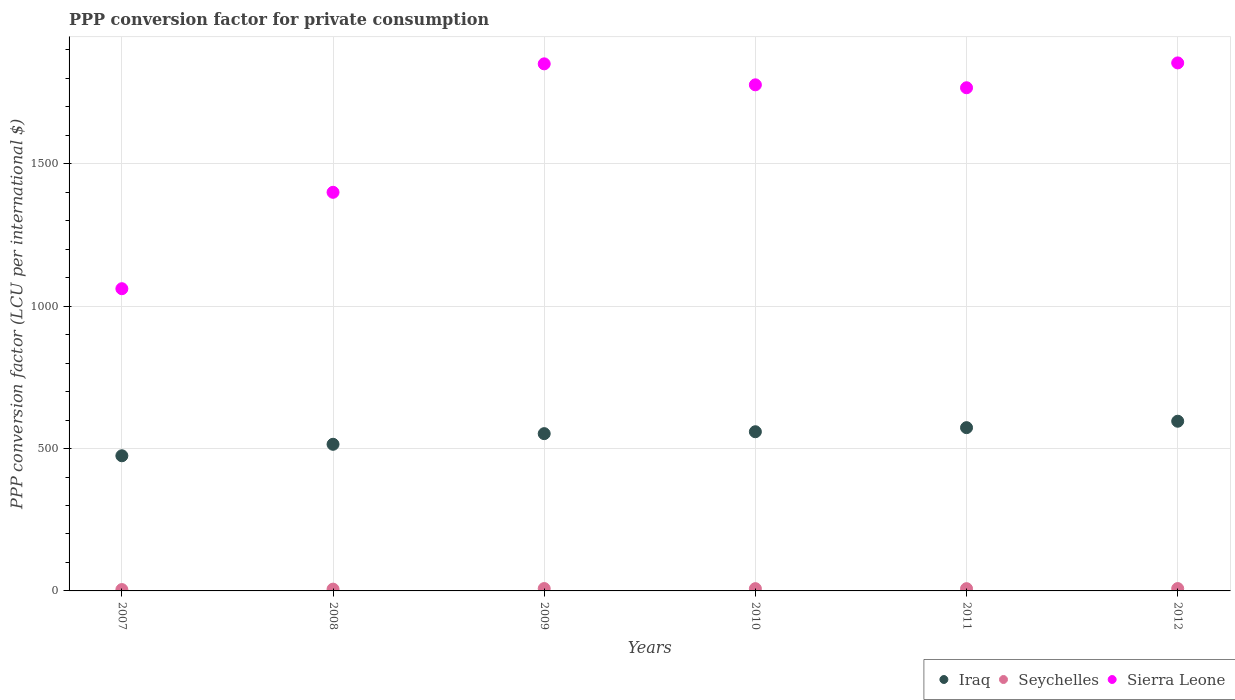How many different coloured dotlines are there?
Provide a short and direct response. 3. What is the PPP conversion factor for private consumption in Sierra Leone in 2009?
Your answer should be very brief. 1851.15. Across all years, what is the maximum PPP conversion factor for private consumption in Iraq?
Give a very brief answer. 596. Across all years, what is the minimum PPP conversion factor for private consumption in Sierra Leone?
Ensure brevity in your answer.  1061.41. In which year was the PPP conversion factor for private consumption in Sierra Leone maximum?
Your answer should be compact. 2012. What is the total PPP conversion factor for private consumption in Seychelles in the graph?
Keep it short and to the point. 43.39. What is the difference between the PPP conversion factor for private consumption in Iraq in 2009 and that in 2010?
Offer a very short reply. -6.73. What is the difference between the PPP conversion factor for private consumption in Iraq in 2007 and the PPP conversion factor for private consumption in Sierra Leone in 2008?
Keep it short and to the point. -925.34. What is the average PPP conversion factor for private consumption in Sierra Leone per year?
Your answer should be very brief. 1618.62. In the year 2010, what is the difference between the PPP conversion factor for private consumption in Sierra Leone and PPP conversion factor for private consumption in Seychelles?
Offer a terse response. 1769.55. What is the ratio of the PPP conversion factor for private consumption in Sierra Leone in 2008 to that in 2011?
Offer a terse response. 0.79. Is the difference between the PPP conversion factor for private consumption in Sierra Leone in 2007 and 2010 greater than the difference between the PPP conversion factor for private consumption in Seychelles in 2007 and 2010?
Give a very brief answer. No. What is the difference between the highest and the second highest PPP conversion factor for private consumption in Seychelles?
Keep it short and to the point. 0.01. What is the difference between the highest and the lowest PPP conversion factor for private consumption in Seychelles?
Ensure brevity in your answer.  3.54. In how many years, is the PPP conversion factor for private consumption in Iraq greater than the average PPP conversion factor for private consumption in Iraq taken over all years?
Offer a terse response. 4. Is the sum of the PPP conversion factor for private consumption in Sierra Leone in 2007 and 2009 greater than the maximum PPP conversion factor for private consumption in Seychelles across all years?
Offer a terse response. Yes. Is the PPP conversion factor for private consumption in Sierra Leone strictly less than the PPP conversion factor for private consumption in Seychelles over the years?
Provide a succinct answer. No. How many dotlines are there?
Your answer should be very brief. 3. Does the graph contain any zero values?
Your answer should be compact. No. How many legend labels are there?
Your response must be concise. 3. How are the legend labels stacked?
Provide a short and direct response. Horizontal. What is the title of the graph?
Offer a terse response. PPP conversion factor for private consumption. What is the label or title of the X-axis?
Offer a terse response. Years. What is the label or title of the Y-axis?
Give a very brief answer. PPP conversion factor (LCU per international $). What is the PPP conversion factor (LCU per international $) in Iraq in 2007?
Offer a very short reply. 474.66. What is the PPP conversion factor (LCU per international $) of Seychelles in 2007?
Your answer should be very brief. 4.74. What is the PPP conversion factor (LCU per international $) in Sierra Leone in 2007?
Provide a succinct answer. 1061.41. What is the PPP conversion factor (LCU per international $) in Iraq in 2008?
Offer a terse response. 515. What is the PPP conversion factor (LCU per international $) of Seychelles in 2008?
Give a very brief answer. 6.25. What is the PPP conversion factor (LCU per international $) in Sierra Leone in 2008?
Offer a very short reply. 1400.01. What is the PPP conversion factor (LCU per international $) of Iraq in 2009?
Keep it short and to the point. 552.36. What is the PPP conversion factor (LCU per international $) in Seychelles in 2009?
Ensure brevity in your answer.  8.27. What is the PPP conversion factor (LCU per international $) in Sierra Leone in 2009?
Give a very brief answer. 1851.15. What is the PPP conversion factor (LCU per international $) of Iraq in 2010?
Your answer should be very brief. 559.09. What is the PPP conversion factor (LCU per international $) in Seychelles in 2010?
Your answer should be very brief. 7.94. What is the PPP conversion factor (LCU per international $) of Sierra Leone in 2010?
Offer a very short reply. 1777.49. What is the PPP conversion factor (LCU per international $) of Iraq in 2011?
Give a very brief answer. 573.42. What is the PPP conversion factor (LCU per international $) in Seychelles in 2011?
Give a very brief answer. 7.9. What is the PPP conversion factor (LCU per international $) of Sierra Leone in 2011?
Ensure brevity in your answer.  1767.19. What is the PPP conversion factor (LCU per international $) of Iraq in 2012?
Provide a short and direct response. 596. What is the PPP conversion factor (LCU per international $) of Seychelles in 2012?
Offer a very short reply. 8.29. What is the PPP conversion factor (LCU per international $) in Sierra Leone in 2012?
Your answer should be compact. 1854.47. Across all years, what is the maximum PPP conversion factor (LCU per international $) of Iraq?
Provide a succinct answer. 596. Across all years, what is the maximum PPP conversion factor (LCU per international $) of Seychelles?
Your answer should be very brief. 8.29. Across all years, what is the maximum PPP conversion factor (LCU per international $) in Sierra Leone?
Keep it short and to the point. 1854.47. Across all years, what is the minimum PPP conversion factor (LCU per international $) in Iraq?
Give a very brief answer. 474.66. Across all years, what is the minimum PPP conversion factor (LCU per international $) in Seychelles?
Your answer should be compact. 4.74. Across all years, what is the minimum PPP conversion factor (LCU per international $) in Sierra Leone?
Provide a succinct answer. 1061.41. What is the total PPP conversion factor (LCU per international $) in Iraq in the graph?
Your response must be concise. 3270.52. What is the total PPP conversion factor (LCU per international $) of Seychelles in the graph?
Make the answer very short. 43.39. What is the total PPP conversion factor (LCU per international $) in Sierra Leone in the graph?
Your answer should be compact. 9711.71. What is the difference between the PPP conversion factor (LCU per international $) in Iraq in 2007 and that in 2008?
Provide a succinct answer. -40.33. What is the difference between the PPP conversion factor (LCU per international $) of Seychelles in 2007 and that in 2008?
Your answer should be compact. -1.51. What is the difference between the PPP conversion factor (LCU per international $) in Sierra Leone in 2007 and that in 2008?
Your answer should be very brief. -338.6. What is the difference between the PPP conversion factor (LCU per international $) in Iraq in 2007 and that in 2009?
Keep it short and to the point. -77.7. What is the difference between the PPP conversion factor (LCU per international $) of Seychelles in 2007 and that in 2009?
Your answer should be very brief. -3.53. What is the difference between the PPP conversion factor (LCU per international $) of Sierra Leone in 2007 and that in 2009?
Keep it short and to the point. -789.74. What is the difference between the PPP conversion factor (LCU per international $) of Iraq in 2007 and that in 2010?
Give a very brief answer. -84.42. What is the difference between the PPP conversion factor (LCU per international $) of Seychelles in 2007 and that in 2010?
Your answer should be very brief. -3.2. What is the difference between the PPP conversion factor (LCU per international $) in Sierra Leone in 2007 and that in 2010?
Offer a very short reply. -716.08. What is the difference between the PPP conversion factor (LCU per international $) of Iraq in 2007 and that in 2011?
Your answer should be very brief. -98.76. What is the difference between the PPP conversion factor (LCU per international $) of Seychelles in 2007 and that in 2011?
Provide a short and direct response. -3.15. What is the difference between the PPP conversion factor (LCU per international $) of Sierra Leone in 2007 and that in 2011?
Keep it short and to the point. -705.78. What is the difference between the PPP conversion factor (LCU per international $) of Iraq in 2007 and that in 2012?
Give a very brief answer. -121.34. What is the difference between the PPP conversion factor (LCU per international $) in Seychelles in 2007 and that in 2012?
Offer a terse response. -3.54. What is the difference between the PPP conversion factor (LCU per international $) in Sierra Leone in 2007 and that in 2012?
Keep it short and to the point. -793.06. What is the difference between the PPP conversion factor (LCU per international $) in Iraq in 2008 and that in 2009?
Your answer should be very brief. -37.36. What is the difference between the PPP conversion factor (LCU per international $) of Seychelles in 2008 and that in 2009?
Provide a succinct answer. -2.02. What is the difference between the PPP conversion factor (LCU per international $) of Sierra Leone in 2008 and that in 2009?
Offer a very short reply. -451.15. What is the difference between the PPP conversion factor (LCU per international $) of Iraq in 2008 and that in 2010?
Your response must be concise. -44.09. What is the difference between the PPP conversion factor (LCU per international $) of Seychelles in 2008 and that in 2010?
Provide a succinct answer. -1.69. What is the difference between the PPP conversion factor (LCU per international $) in Sierra Leone in 2008 and that in 2010?
Provide a short and direct response. -377.48. What is the difference between the PPP conversion factor (LCU per international $) of Iraq in 2008 and that in 2011?
Make the answer very short. -58.42. What is the difference between the PPP conversion factor (LCU per international $) in Seychelles in 2008 and that in 2011?
Your answer should be compact. -1.64. What is the difference between the PPP conversion factor (LCU per international $) in Sierra Leone in 2008 and that in 2011?
Offer a terse response. -367.18. What is the difference between the PPP conversion factor (LCU per international $) of Iraq in 2008 and that in 2012?
Provide a succinct answer. -81. What is the difference between the PPP conversion factor (LCU per international $) of Seychelles in 2008 and that in 2012?
Keep it short and to the point. -2.03. What is the difference between the PPP conversion factor (LCU per international $) of Sierra Leone in 2008 and that in 2012?
Give a very brief answer. -454.46. What is the difference between the PPP conversion factor (LCU per international $) in Iraq in 2009 and that in 2010?
Your response must be concise. -6.73. What is the difference between the PPP conversion factor (LCU per international $) in Seychelles in 2009 and that in 2010?
Ensure brevity in your answer.  0.33. What is the difference between the PPP conversion factor (LCU per international $) in Sierra Leone in 2009 and that in 2010?
Offer a very short reply. 73.67. What is the difference between the PPP conversion factor (LCU per international $) in Iraq in 2009 and that in 2011?
Make the answer very short. -21.06. What is the difference between the PPP conversion factor (LCU per international $) of Seychelles in 2009 and that in 2011?
Give a very brief answer. 0.38. What is the difference between the PPP conversion factor (LCU per international $) of Sierra Leone in 2009 and that in 2011?
Provide a short and direct response. 83.96. What is the difference between the PPP conversion factor (LCU per international $) of Iraq in 2009 and that in 2012?
Your answer should be compact. -43.64. What is the difference between the PPP conversion factor (LCU per international $) in Seychelles in 2009 and that in 2012?
Your answer should be compact. -0.01. What is the difference between the PPP conversion factor (LCU per international $) in Sierra Leone in 2009 and that in 2012?
Offer a terse response. -3.32. What is the difference between the PPP conversion factor (LCU per international $) in Iraq in 2010 and that in 2011?
Ensure brevity in your answer.  -14.33. What is the difference between the PPP conversion factor (LCU per international $) in Seychelles in 2010 and that in 2011?
Ensure brevity in your answer.  0.05. What is the difference between the PPP conversion factor (LCU per international $) in Sierra Leone in 2010 and that in 2011?
Provide a short and direct response. 10.3. What is the difference between the PPP conversion factor (LCU per international $) of Iraq in 2010 and that in 2012?
Give a very brief answer. -36.92. What is the difference between the PPP conversion factor (LCU per international $) in Seychelles in 2010 and that in 2012?
Give a very brief answer. -0.34. What is the difference between the PPP conversion factor (LCU per international $) in Sierra Leone in 2010 and that in 2012?
Your answer should be very brief. -76.98. What is the difference between the PPP conversion factor (LCU per international $) of Iraq in 2011 and that in 2012?
Your response must be concise. -22.58. What is the difference between the PPP conversion factor (LCU per international $) of Seychelles in 2011 and that in 2012?
Keep it short and to the point. -0.39. What is the difference between the PPP conversion factor (LCU per international $) of Sierra Leone in 2011 and that in 2012?
Your answer should be very brief. -87.28. What is the difference between the PPP conversion factor (LCU per international $) of Iraq in 2007 and the PPP conversion factor (LCU per international $) of Seychelles in 2008?
Offer a terse response. 468.41. What is the difference between the PPP conversion factor (LCU per international $) of Iraq in 2007 and the PPP conversion factor (LCU per international $) of Sierra Leone in 2008?
Offer a terse response. -925.34. What is the difference between the PPP conversion factor (LCU per international $) of Seychelles in 2007 and the PPP conversion factor (LCU per international $) of Sierra Leone in 2008?
Offer a very short reply. -1395.26. What is the difference between the PPP conversion factor (LCU per international $) of Iraq in 2007 and the PPP conversion factor (LCU per international $) of Seychelles in 2009?
Give a very brief answer. 466.39. What is the difference between the PPP conversion factor (LCU per international $) in Iraq in 2007 and the PPP conversion factor (LCU per international $) in Sierra Leone in 2009?
Make the answer very short. -1376.49. What is the difference between the PPP conversion factor (LCU per international $) of Seychelles in 2007 and the PPP conversion factor (LCU per international $) of Sierra Leone in 2009?
Your response must be concise. -1846.41. What is the difference between the PPP conversion factor (LCU per international $) of Iraq in 2007 and the PPP conversion factor (LCU per international $) of Seychelles in 2010?
Your answer should be compact. 466.72. What is the difference between the PPP conversion factor (LCU per international $) of Iraq in 2007 and the PPP conversion factor (LCU per international $) of Sierra Leone in 2010?
Your response must be concise. -1302.82. What is the difference between the PPP conversion factor (LCU per international $) of Seychelles in 2007 and the PPP conversion factor (LCU per international $) of Sierra Leone in 2010?
Your answer should be very brief. -1772.74. What is the difference between the PPP conversion factor (LCU per international $) in Iraq in 2007 and the PPP conversion factor (LCU per international $) in Seychelles in 2011?
Your answer should be very brief. 466.77. What is the difference between the PPP conversion factor (LCU per international $) of Iraq in 2007 and the PPP conversion factor (LCU per international $) of Sierra Leone in 2011?
Offer a terse response. -1292.53. What is the difference between the PPP conversion factor (LCU per international $) in Seychelles in 2007 and the PPP conversion factor (LCU per international $) in Sierra Leone in 2011?
Provide a succinct answer. -1762.45. What is the difference between the PPP conversion factor (LCU per international $) of Iraq in 2007 and the PPP conversion factor (LCU per international $) of Seychelles in 2012?
Offer a terse response. 466.38. What is the difference between the PPP conversion factor (LCU per international $) in Iraq in 2007 and the PPP conversion factor (LCU per international $) in Sierra Leone in 2012?
Your answer should be very brief. -1379.81. What is the difference between the PPP conversion factor (LCU per international $) of Seychelles in 2007 and the PPP conversion factor (LCU per international $) of Sierra Leone in 2012?
Offer a terse response. -1849.73. What is the difference between the PPP conversion factor (LCU per international $) of Iraq in 2008 and the PPP conversion factor (LCU per international $) of Seychelles in 2009?
Your answer should be very brief. 506.73. What is the difference between the PPP conversion factor (LCU per international $) of Iraq in 2008 and the PPP conversion factor (LCU per international $) of Sierra Leone in 2009?
Give a very brief answer. -1336.16. What is the difference between the PPP conversion factor (LCU per international $) of Seychelles in 2008 and the PPP conversion factor (LCU per international $) of Sierra Leone in 2009?
Offer a very short reply. -1844.9. What is the difference between the PPP conversion factor (LCU per international $) in Iraq in 2008 and the PPP conversion factor (LCU per international $) in Seychelles in 2010?
Give a very brief answer. 507.05. What is the difference between the PPP conversion factor (LCU per international $) of Iraq in 2008 and the PPP conversion factor (LCU per international $) of Sierra Leone in 2010?
Provide a short and direct response. -1262.49. What is the difference between the PPP conversion factor (LCU per international $) of Seychelles in 2008 and the PPP conversion factor (LCU per international $) of Sierra Leone in 2010?
Your response must be concise. -1771.23. What is the difference between the PPP conversion factor (LCU per international $) of Iraq in 2008 and the PPP conversion factor (LCU per international $) of Seychelles in 2011?
Provide a succinct answer. 507.1. What is the difference between the PPP conversion factor (LCU per international $) in Iraq in 2008 and the PPP conversion factor (LCU per international $) in Sierra Leone in 2011?
Ensure brevity in your answer.  -1252.19. What is the difference between the PPP conversion factor (LCU per international $) in Seychelles in 2008 and the PPP conversion factor (LCU per international $) in Sierra Leone in 2011?
Make the answer very short. -1760.93. What is the difference between the PPP conversion factor (LCU per international $) in Iraq in 2008 and the PPP conversion factor (LCU per international $) in Seychelles in 2012?
Offer a very short reply. 506.71. What is the difference between the PPP conversion factor (LCU per international $) of Iraq in 2008 and the PPP conversion factor (LCU per international $) of Sierra Leone in 2012?
Offer a very short reply. -1339.47. What is the difference between the PPP conversion factor (LCU per international $) in Seychelles in 2008 and the PPP conversion factor (LCU per international $) in Sierra Leone in 2012?
Your answer should be very brief. -1848.21. What is the difference between the PPP conversion factor (LCU per international $) of Iraq in 2009 and the PPP conversion factor (LCU per international $) of Seychelles in 2010?
Offer a very short reply. 544.42. What is the difference between the PPP conversion factor (LCU per international $) in Iraq in 2009 and the PPP conversion factor (LCU per international $) in Sierra Leone in 2010?
Provide a short and direct response. -1225.13. What is the difference between the PPP conversion factor (LCU per international $) in Seychelles in 2009 and the PPP conversion factor (LCU per international $) in Sierra Leone in 2010?
Your answer should be very brief. -1769.22. What is the difference between the PPP conversion factor (LCU per international $) in Iraq in 2009 and the PPP conversion factor (LCU per international $) in Seychelles in 2011?
Provide a succinct answer. 544.46. What is the difference between the PPP conversion factor (LCU per international $) of Iraq in 2009 and the PPP conversion factor (LCU per international $) of Sierra Leone in 2011?
Your answer should be very brief. -1214.83. What is the difference between the PPP conversion factor (LCU per international $) of Seychelles in 2009 and the PPP conversion factor (LCU per international $) of Sierra Leone in 2011?
Your response must be concise. -1758.92. What is the difference between the PPP conversion factor (LCU per international $) of Iraq in 2009 and the PPP conversion factor (LCU per international $) of Seychelles in 2012?
Provide a succinct answer. 544.07. What is the difference between the PPP conversion factor (LCU per international $) in Iraq in 2009 and the PPP conversion factor (LCU per international $) in Sierra Leone in 2012?
Ensure brevity in your answer.  -1302.11. What is the difference between the PPP conversion factor (LCU per international $) of Seychelles in 2009 and the PPP conversion factor (LCU per international $) of Sierra Leone in 2012?
Your answer should be compact. -1846.2. What is the difference between the PPP conversion factor (LCU per international $) in Iraq in 2010 and the PPP conversion factor (LCU per international $) in Seychelles in 2011?
Offer a very short reply. 551.19. What is the difference between the PPP conversion factor (LCU per international $) of Iraq in 2010 and the PPP conversion factor (LCU per international $) of Sierra Leone in 2011?
Keep it short and to the point. -1208.1. What is the difference between the PPP conversion factor (LCU per international $) in Seychelles in 2010 and the PPP conversion factor (LCU per international $) in Sierra Leone in 2011?
Provide a succinct answer. -1759.25. What is the difference between the PPP conversion factor (LCU per international $) in Iraq in 2010 and the PPP conversion factor (LCU per international $) in Seychelles in 2012?
Offer a very short reply. 550.8. What is the difference between the PPP conversion factor (LCU per international $) in Iraq in 2010 and the PPP conversion factor (LCU per international $) in Sierra Leone in 2012?
Give a very brief answer. -1295.38. What is the difference between the PPP conversion factor (LCU per international $) in Seychelles in 2010 and the PPP conversion factor (LCU per international $) in Sierra Leone in 2012?
Your response must be concise. -1846.53. What is the difference between the PPP conversion factor (LCU per international $) of Iraq in 2011 and the PPP conversion factor (LCU per international $) of Seychelles in 2012?
Ensure brevity in your answer.  565.13. What is the difference between the PPP conversion factor (LCU per international $) of Iraq in 2011 and the PPP conversion factor (LCU per international $) of Sierra Leone in 2012?
Offer a very short reply. -1281.05. What is the difference between the PPP conversion factor (LCU per international $) of Seychelles in 2011 and the PPP conversion factor (LCU per international $) of Sierra Leone in 2012?
Offer a terse response. -1846.57. What is the average PPP conversion factor (LCU per international $) of Iraq per year?
Your answer should be very brief. 545.09. What is the average PPP conversion factor (LCU per international $) in Seychelles per year?
Provide a succinct answer. 7.23. What is the average PPP conversion factor (LCU per international $) in Sierra Leone per year?
Keep it short and to the point. 1618.62. In the year 2007, what is the difference between the PPP conversion factor (LCU per international $) in Iraq and PPP conversion factor (LCU per international $) in Seychelles?
Provide a short and direct response. 469.92. In the year 2007, what is the difference between the PPP conversion factor (LCU per international $) in Iraq and PPP conversion factor (LCU per international $) in Sierra Leone?
Provide a short and direct response. -586.75. In the year 2007, what is the difference between the PPP conversion factor (LCU per international $) in Seychelles and PPP conversion factor (LCU per international $) in Sierra Leone?
Make the answer very short. -1056.66. In the year 2008, what is the difference between the PPP conversion factor (LCU per international $) of Iraq and PPP conversion factor (LCU per international $) of Seychelles?
Provide a short and direct response. 508.74. In the year 2008, what is the difference between the PPP conversion factor (LCU per international $) of Iraq and PPP conversion factor (LCU per international $) of Sierra Leone?
Ensure brevity in your answer.  -885.01. In the year 2008, what is the difference between the PPP conversion factor (LCU per international $) of Seychelles and PPP conversion factor (LCU per international $) of Sierra Leone?
Give a very brief answer. -1393.75. In the year 2009, what is the difference between the PPP conversion factor (LCU per international $) of Iraq and PPP conversion factor (LCU per international $) of Seychelles?
Your answer should be compact. 544.09. In the year 2009, what is the difference between the PPP conversion factor (LCU per international $) in Iraq and PPP conversion factor (LCU per international $) in Sierra Leone?
Your response must be concise. -1298.79. In the year 2009, what is the difference between the PPP conversion factor (LCU per international $) in Seychelles and PPP conversion factor (LCU per international $) in Sierra Leone?
Keep it short and to the point. -1842.88. In the year 2010, what is the difference between the PPP conversion factor (LCU per international $) in Iraq and PPP conversion factor (LCU per international $) in Seychelles?
Give a very brief answer. 551.14. In the year 2010, what is the difference between the PPP conversion factor (LCU per international $) in Iraq and PPP conversion factor (LCU per international $) in Sierra Leone?
Keep it short and to the point. -1218.4. In the year 2010, what is the difference between the PPP conversion factor (LCU per international $) in Seychelles and PPP conversion factor (LCU per international $) in Sierra Leone?
Keep it short and to the point. -1769.55. In the year 2011, what is the difference between the PPP conversion factor (LCU per international $) of Iraq and PPP conversion factor (LCU per international $) of Seychelles?
Make the answer very short. 565.52. In the year 2011, what is the difference between the PPP conversion factor (LCU per international $) in Iraq and PPP conversion factor (LCU per international $) in Sierra Leone?
Provide a short and direct response. -1193.77. In the year 2011, what is the difference between the PPP conversion factor (LCU per international $) of Seychelles and PPP conversion factor (LCU per international $) of Sierra Leone?
Your answer should be very brief. -1759.29. In the year 2012, what is the difference between the PPP conversion factor (LCU per international $) of Iraq and PPP conversion factor (LCU per international $) of Seychelles?
Provide a succinct answer. 587.72. In the year 2012, what is the difference between the PPP conversion factor (LCU per international $) of Iraq and PPP conversion factor (LCU per international $) of Sierra Leone?
Provide a short and direct response. -1258.47. In the year 2012, what is the difference between the PPP conversion factor (LCU per international $) in Seychelles and PPP conversion factor (LCU per international $) in Sierra Leone?
Give a very brief answer. -1846.18. What is the ratio of the PPP conversion factor (LCU per international $) of Iraq in 2007 to that in 2008?
Keep it short and to the point. 0.92. What is the ratio of the PPP conversion factor (LCU per international $) in Seychelles in 2007 to that in 2008?
Ensure brevity in your answer.  0.76. What is the ratio of the PPP conversion factor (LCU per international $) of Sierra Leone in 2007 to that in 2008?
Provide a succinct answer. 0.76. What is the ratio of the PPP conversion factor (LCU per international $) of Iraq in 2007 to that in 2009?
Your answer should be compact. 0.86. What is the ratio of the PPP conversion factor (LCU per international $) in Seychelles in 2007 to that in 2009?
Your response must be concise. 0.57. What is the ratio of the PPP conversion factor (LCU per international $) in Sierra Leone in 2007 to that in 2009?
Provide a short and direct response. 0.57. What is the ratio of the PPP conversion factor (LCU per international $) in Iraq in 2007 to that in 2010?
Ensure brevity in your answer.  0.85. What is the ratio of the PPP conversion factor (LCU per international $) of Seychelles in 2007 to that in 2010?
Offer a very short reply. 0.6. What is the ratio of the PPP conversion factor (LCU per international $) in Sierra Leone in 2007 to that in 2010?
Keep it short and to the point. 0.6. What is the ratio of the PPP conversion factor (LCU per international $) of Iraq in 2007 to that in 2011?
Your answer should be compact. 0.83. What is the ratio of the PPP conversion factor (LCU per international $) of Seychelles in 2007 to that in 2011?
Offer a terse response. 0.6. What is the ratio of the PPP conversion factor (LCU per international $) in Sierra Leone in 2007 to that in 2011?
Provide a short and direct response. 0.6. What is the ratio of the PPP conversion factor (LCU per international $) of Iraq in 2007 to that in 2012?
Give a very brief answer. 0.8. What is the ratio of the PPP conversion factor (LCU per international $) of Seychelles in 2007 to that in 2012?
Give a very brief answer. 0.57. What is the ratio of the PPP conversion factor (LCU per international $) in Sierra Leone in 2007 to that in 2012?
Make the answer very short. 0.57. What is the ratio of the PPP conversion factor (LCU per international $) in Iraq in 2008 to that in 2009?
Offer a terse response. 0.93. What is the ratio of the PPP conversion factor (LCU per international $) of Seychelles in 2008 to that in 2009?
Give a very brief answer. 0.76. What is the ratio of the PPP conversion factor (LCU per international $) in Sierra Leone in 2008 to that in 2009?
Ensure brevity in your answer.  0.76. What is the ratio of the PPP conversion factor (LCU per international $) of Iraq in 2008 to that in 2010?
Offer a very short reply. 0.92. What is the ratio of the PPP conversion factor (LCU per international $) in Seychelles in 2008 to that in 2010?
Provide a succinct answer. 0.79. What is the ratio of the PPP conversion factor (LCU per international $) of Sierra Leone in 2008 to that in 2010?
Your answer should be compact. 0.79. What is the ratio of the PPP conversion factor (LCU per international $) of Iraq in 2008 to that in 2011?
Offer a terse response. 0.9. What is the ratio of the PPP conversion factor (LCU per international $) of Seychelles in 2008 to that in 2011?
Make the answer very short. 0.79. What is the ratio of the PPP conversion factor (LCU per international $) in Sierra Leone in 2008 to that in 2011?
Provide a succinct answer. 0.79. What is the ratio of the PPP conversion factor (LCU per international $) in Iraq in 2008 to that in 2012?
Your answer should be compact. 0.86. What is the ratio of the PPP conversion factor (LCU per international $) in Seychelles in 2008 to that in 2012?
Your answer should be very brief. 0.75. What is the ratio of the PPP conversion factor (LCU per international $) of Sierra Leone in 2008 to that in 2012?
Ensure brevity in your answer.  0.75. What is the ratio of the PPP conversion factor (LCU per international $) in Seychelles in 2009 to that in 2010?
Provide a succinct answer. 1.04. What is the ratio of the PPP conversion factor (LCU per international $) in Sierra Leone in 2009 to that in 2010?
Provide a succinct answer. 1.04. What is the ratio of the PPP conversion factor (LCU per international $) of Iraq in 2009 to that in 2011?
Your response must be concise. 0.96. What is the ratio of the PPP conversion factor (LCU per international $) of Seychelles in 2009 to that in 2011?
Keep it short and to the point. 1.05. What is the ratio of the PPP conversion factor (LCU per international $) in Sierra Leone in 2009 to that in 2011?
Your answer should be compact. 1.05. What is the ratio of the PPP conversion factor (LCU per international $) of Iraq in 2009 to that in 2012?
Offer a terse response. 0.93. What is the ratio of the PPP conversion factor (LCU per international $) of Sierra Leone in 2009 to that in 2012?
Offer a very short reply. 1. What is the ratio of the PPP conversion factor (LCU per international $) in Seychelles in 2010 to that in 2011?
Give a very brief answer. 1.01. What is the ratio of the PPP conversion factor (LCU per international $) in Sierra Leone in 2010 to that in 2011?
Give a very brief answer. 1.01. What is the ratio of the PPP conversion factor (LCU per international $) of Iraq in 2010 to that in 2012?
Offer a very short reply. 0.94. What is the ratio of the PPP conversion factor (LCU per international $) in Seychelles in 2010 to that in 2012?
Your answer should be very brief. 0.96. What is the ratio of the PPP conversion factor (LCU per international $) in Sierra Leone in 2010 to that in 2012?
Keep it short and to the point. 0.96. What is the ratio of the PPP conversion factor (LCU per international $) of Iraq in 2011 to that in 2012?
Provide a short and direct response. 0.96. What is the ratio of the PPP conversion factor (LCU per international $) of Seychelles in 2011 to that in 2012?
Offer a very short reply. 0.95. What is the ratio of the PPP conversion factor (LCU per international $) in Sierra Leone in 2011 to that in 2012?
Your answer should be very brief. 0.95. What is the difference between the highest and the second highest PPP conversion factor (LCU per international $) in Iraq?
Provide a succinct answer. 22.58. What is the difference between the highest and the second highest PPP conversion factor (LCU per international $) in Seychelles?
Your answer should be very brief. 0.01. What is the difference between the highest and the second highest PPP conversion factor (LCU per international $) of Sierra Leone?
Ensure brevity in your answer.  3.32. What is the difference between the highest and the lowest PPP conversion factor (LCU per international $) of Iraq?
Give a very brief answer. 121.34. What is the difference between the highest and the lowest PPP conversion factor (LCU per international $) of Seychelles?
Provide a succinct answer. 3.54. What is the difference between the highest and the lowest PPP conversion factor (LCU per international $) in Sierra Leone?
Offer a very short reply. 793.06. 